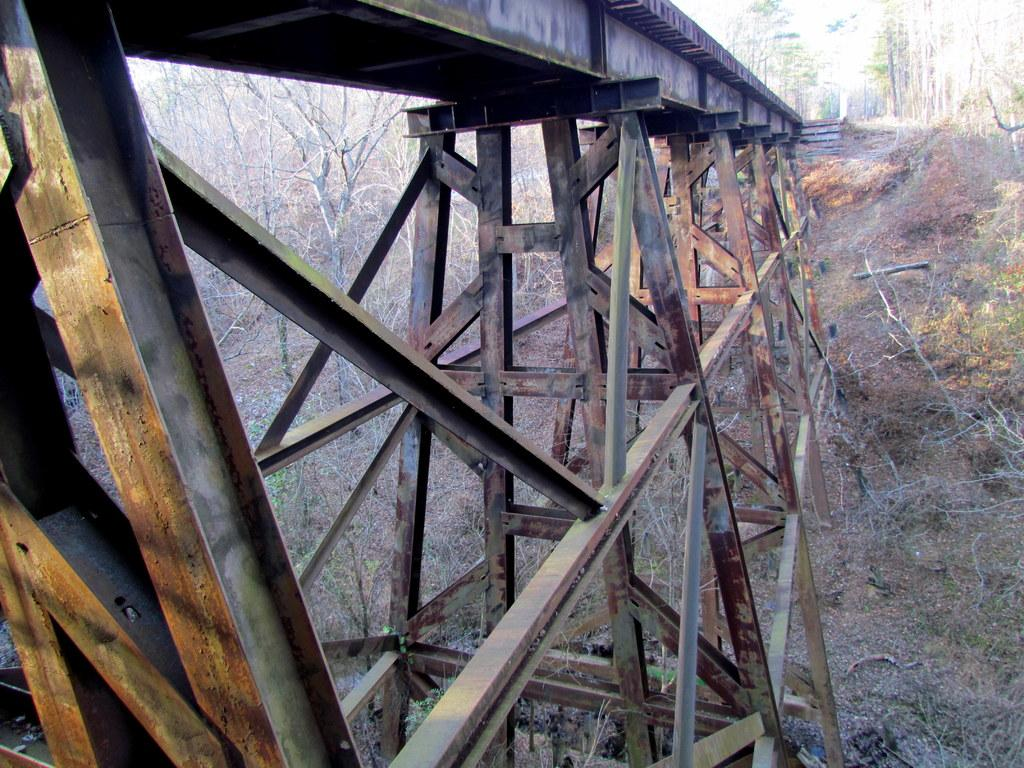What is the primary feature of the landscape in the image? There are many trees in the image. What type of structure can be seen in the image? There is a bridge in the image. What arm is visible holding a flame in the image? There is no arm or flame present in the image; it features trees and a bridge. What type of conversation is happening between the trees in the image? There is no conversation happening between the trees in the image; they are inanimate objects. 